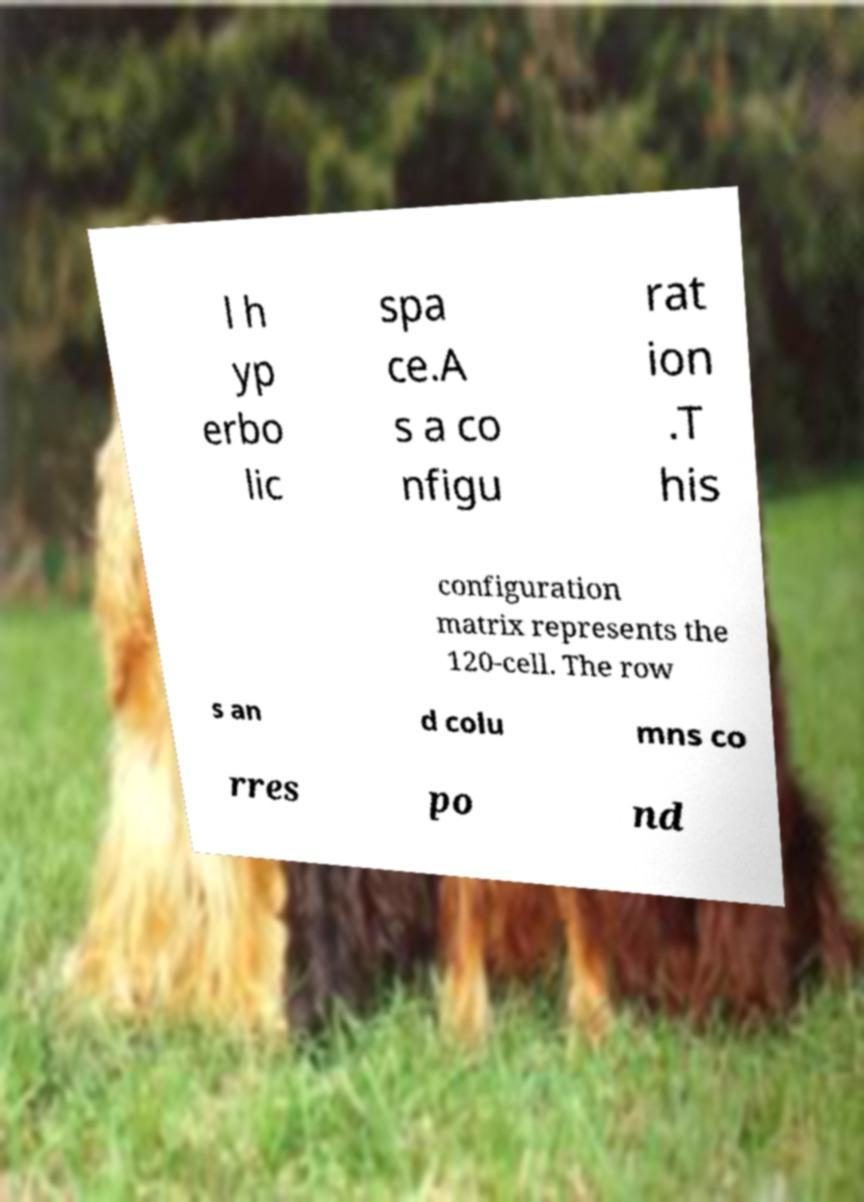Can you read and provide the text displayed in the image?This photo seems to have some interesting text. Can you extract and type it out for me? l h yp erbo lic spa ce.A s a co nfigu rat ion .T his configuration matrix represents the 120-cell. The row s an d colu mns co rres po nd 